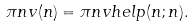Convert formula to latex. <formula><loc_0><loc_0><loc_500><loc_500>\pi n v ( n ) = \pi n v h e l p ( n ; n ) .</formula> 